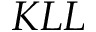<formula> <loc_0><loc_0><loc_500><loc_500>K L L</formula> 